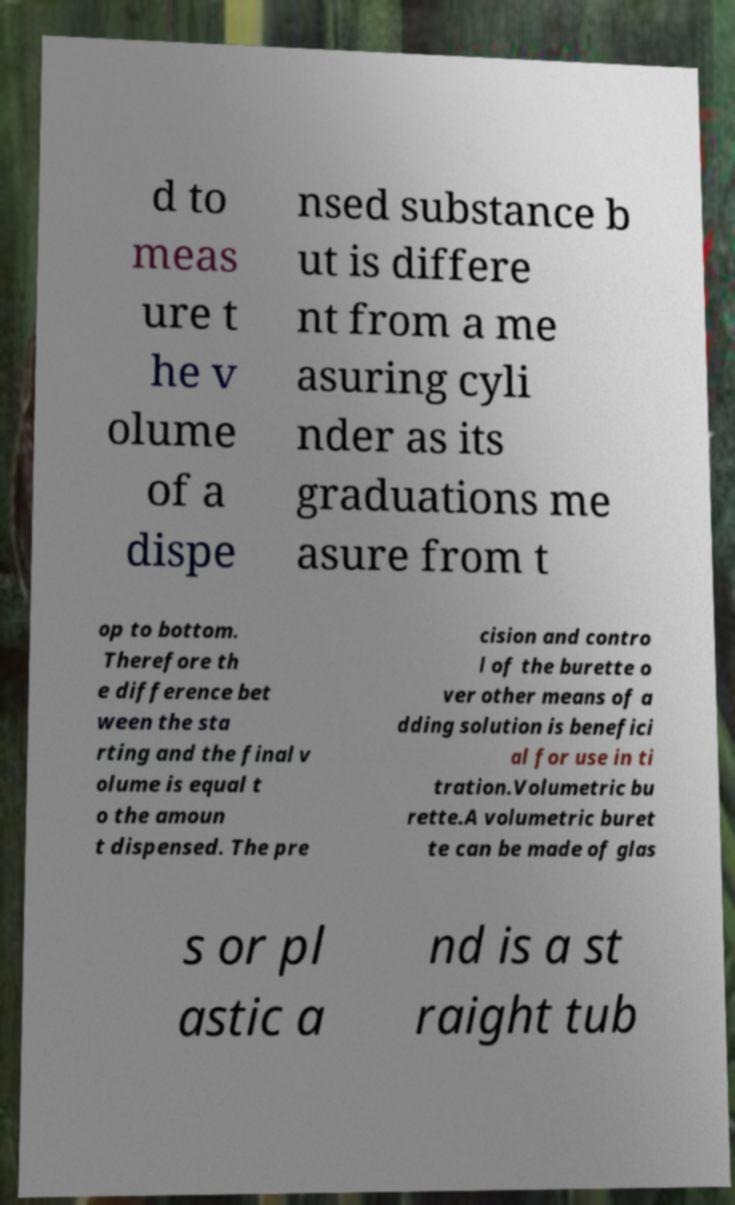Please identify and transcribe the text found in this image. d to meas ure t he v olume of a dispe nsed substance b ut is differe nt from a me asuring cyli nder as its graduations me asure from t op to bottom. Therefore th e difference bet ween the sta rting and the final v olume is equal t o the amoun t dispensed. The pre cision and contro l of the burette o ver other means of a dding solution is benefici al for use in ti tration.Volumetric bu rette.A volumetric buret te can be made of glas s or pl astic a nd is a st raight tub 